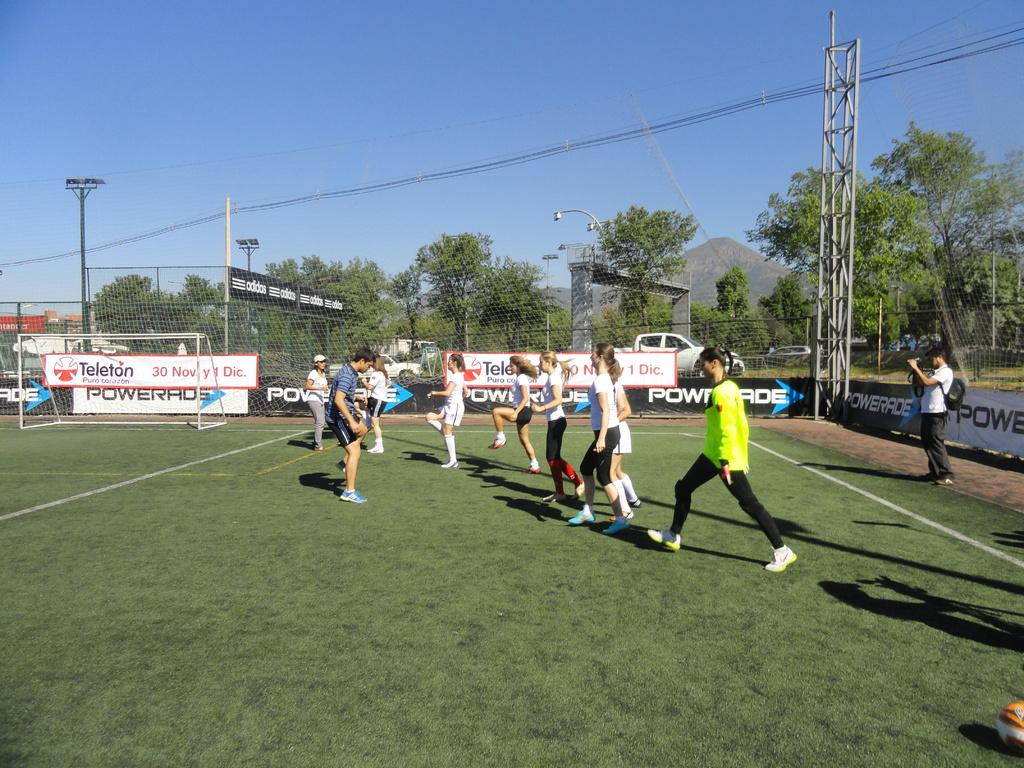<image>
Present a compact description of the photo's key features. guy filming females stretching on soccer field surrounded by powerade signs 